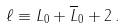Convert formula to latex. <formula><loc_0><loc_0><loc_500><loc_500>\ell \equiv L _ { 0 } + \overline { L } _ { 0 } + 2 \, .</formula> 